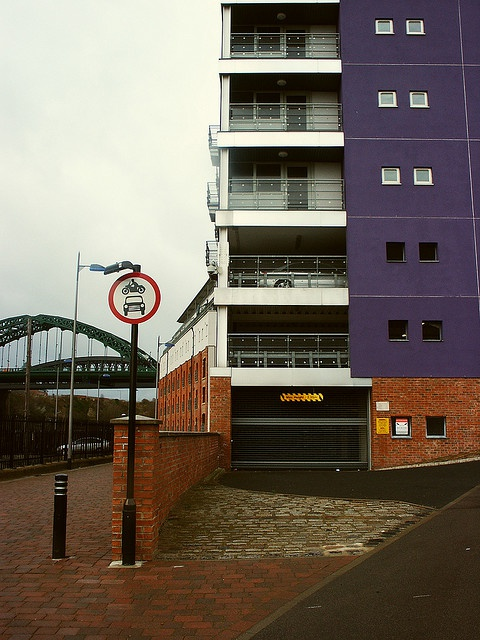Describe the objects in this image and their specific colors. I can see car in ivory, black, gray, darkgray, and darkgreen tones and car in ivory, black, and gray tones in this image. 